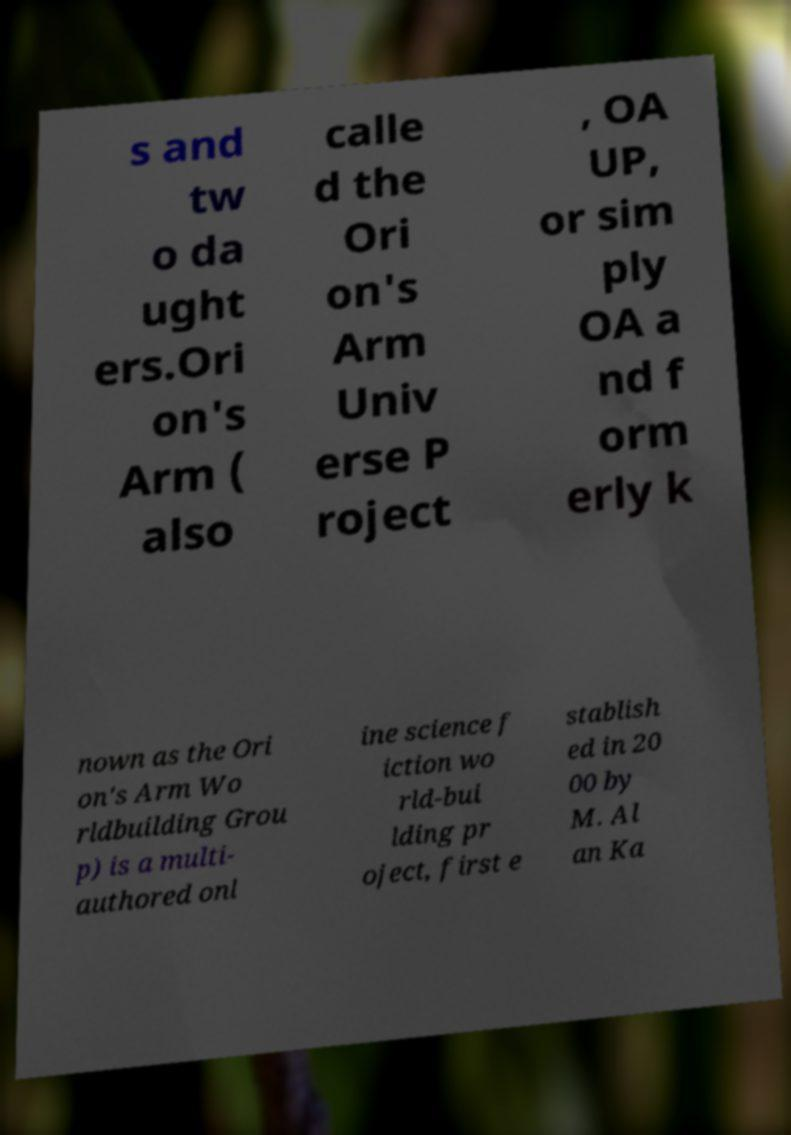I need the written content from this picture converted into text. Can you do that? s and tw o da ught ers.Ori on's Arm ( also calle d the Ori on's Arm Univ erse P roject , OA UP, or sim ply OA a nd f orm erly k nown as the Ori on's Arm Wo rldbuilding Grou p) is a multi- authored onl ine science f iction wo rld-bui lding pr oject, first e stablish ed in 20 00 by M. Al an Ka 